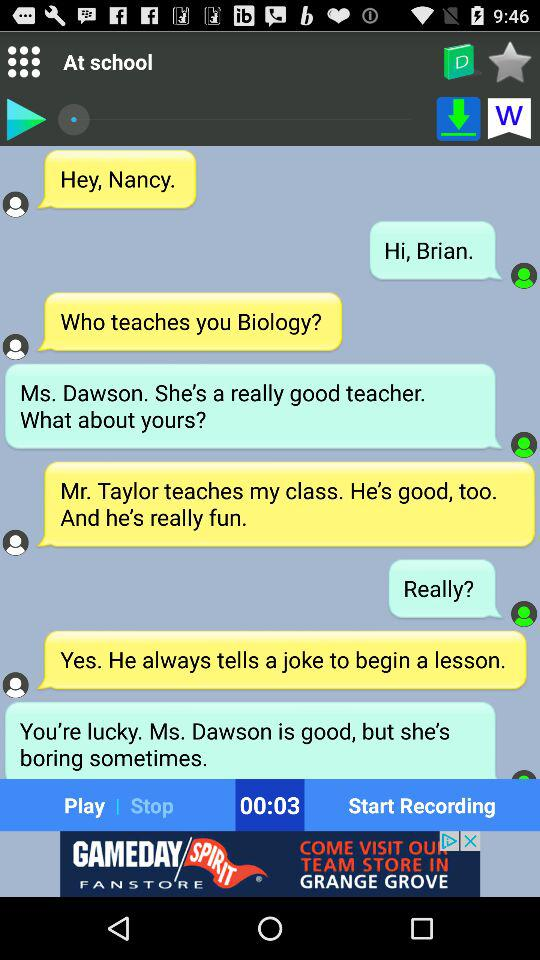What is the location? The location is school. 